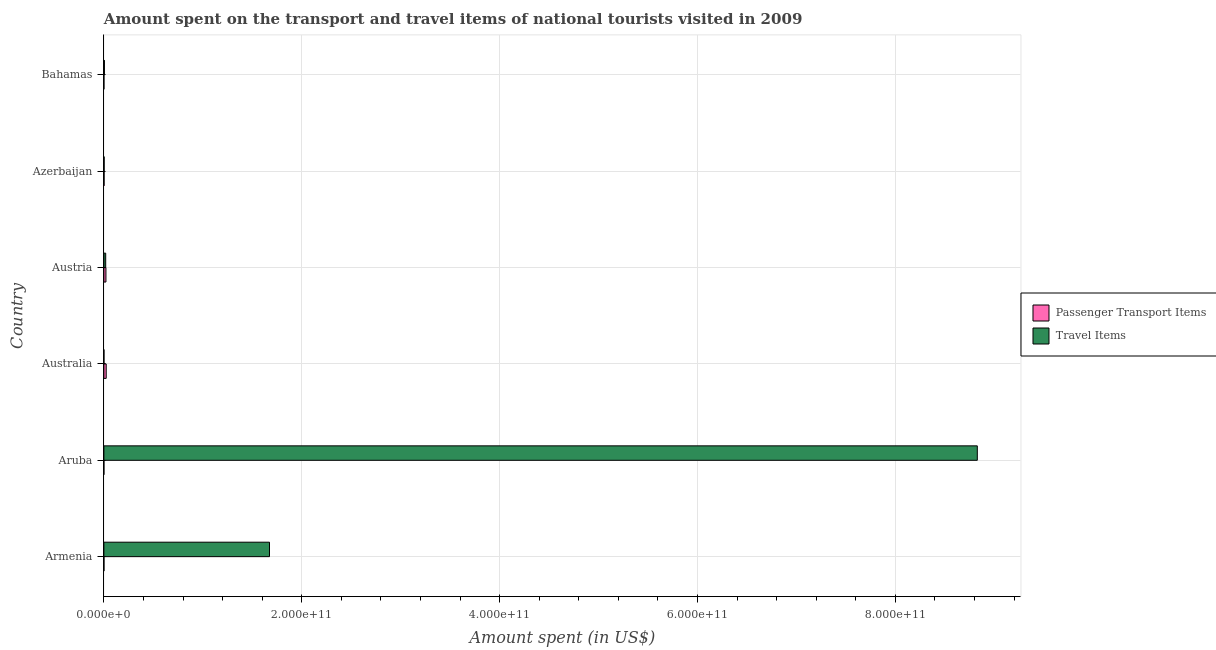How many different coloured bars are there?
Provide a succinct answer. 2. How many groups of bars are there?
Provide a short and direct response. 6. Are the number of bars per tick equal to the number of legend labels?
Provide a short and direct response. Yes. How many bars are there on the 4th tick from the bottom?
Your response must be concise. 2. What is the amount spent on passenger transport items in Aruba?
Offer a terse response. 1.20e+06. Across all countries, what is the maximum amount spent in travel items?
Provide a short and direct response. 8.83e+11. Across all countries, what is the minimum amount spent in travel items?
Keep it short and to the point. 3.90e+07. In which country was the amount spent in travel items maximum?
Keep it short and to the point. Aruba. In which country was the amount spent in travel items minimum?
Ensure brevity in your answer.  Australia. What is the total amount spent in travel items in the graph?
Your answer should be compact. 1.05e+12. What is the difference between the amount spent on passenger transport items in Australia and that in Azerbaijan?
Provide a succinct answer. 2.18e+09. What is the difference between the amount spent in travel items in Australia and the amount spent on passenger transport items in Azerbaijan?
Offer a terse response. -1.27e+08. What is the average amount spent on passenger transport items per country?
Ensure brevity in your answer.  7.70e+08. What is the difference between the amount spent in travel items and amount spent on passenger transport items in Australia?
Keep it short and to the point. -2.30e+09. In how many countries, is the amount spent on passenger transport items greater than 160000000000 US$?
Your answer should be very brief. 0. What is the ratio of the amount spent on passenger transport items in Austria to that in Bahamas?
Give a very brief answer. 187.36. What is the difference between the highest and the second highest amount spent in travel items?
Offer a very short reply. 7.15e+11. What is the difference between the highest and the lowest amount spent on passenger transport items?
Your answer should be very brief. 2.34e+09. In how many countries, is the amount spent on passenger transport items greater than the average amount spent on passenger transport items taken over all countries?
Ensure brevity in your answer.  2. Is the sum of the amount spent in travel items in Aruba and Austria greater than the maximum amount spent on passenger transport items across all countries?
Your response must be concise. Yes. What does the 1st bar from the top in Azerbaijan represents?
Make the answer very short. Travel Items. What does the 1st bar from the bottom in Armenia represents?
Provide a short and direct response. Passenger Transport Items. Are all the bars in the graph horizontal?
Keep it short and to the point. Yes. How many countries are there in the graph?
Keep it short and to the point. 6. What is the difference between two consecutive major ticks on the X-axis?
Provide a short and direct response. 2.00e+11. Are the values on the major ticks of X-axis written in scientific E-notation?
Keep it short and to the point. Yes. How many legend labels are there?
Your answer should be compact. 2. What is the title of the graph?
Give a very brief answer. Amount spent on the transport and travel items of national tourists visited in 2009. What is the label or title of the X-axis?
Provide a short and direct response. Amount spent (in US$). What is the Amount spent (in US$) in Passenger Transport Items in Armenia?
Your answer should be compact. 4.00e+07. What is the Amount spent (in US$) in Travel Items in Armenia?
Ensure brevity in your answer.  1.67e+11. What is the Amount spent (in US$) of Passenger Transport Items in Aruba?
Ensure brevity in your answer.  1.20e+06. What is the Amount spent (in US$) in Travel Items in Aruba?
Keep it short and to the point. 8.83e+11. What is the Amount spent (in US$) in Passenger Transport Items in Australia?
Your response must be concise. 2.34e+09. What is the Amount spent (in US$) in Travel Items in Australia?
Offer a very short reply. 3.90e+07. What is the Amount spent (in US$) of Passenger Transport Items in Austria?
Make the answer very short. 2.06e+09. What is the Amount spent (in US$) in Travel Items in Austria?
Your answer should be very brief. 1.83e+09. What is the Amount spent (in US$) of Passenger Transport Items in Azerbaijan?
Make the answer very short. 1.66e+08. What is the Amount spent (in US$) in Travel Items in Azerbaijan?
Keep it short and to the point. 2.46e+08. What is the Amount spent (in US$) of Passenger Transport Items in Bahamas?
Provide a short and direct response. 1.10e+07. What is the Amount spent (in US$) of Travel Items in Bahamas?
Make the answer very short. 5.34e+08. Across all countries, what is the maximum Amount spent (in US$) of Passenger Transport Items?
Ensure brevity in your answer.  2.34e+09. Across all countries, what is the maximum Amount spent (in US$) of Travel Items?
Provide a short and direct response. 8.83e+11. Across all countries, what is the minimum Amount spent (in US$) in Passenger Transport Items?
Your response must be concise. 1.20e+06. Across all countries, what is the minimum Amount spent (in US$) in Travel Items?
Ensure brevity in your answer.  3.90e+07. What is the total Amount spent (in US$) of Passenger Transport Items in the graph?
Provide a short and direct response. 4.62e+09. What is the total Amount spent (in US$) in Travel Items in the graph?
Provide a short and direct response. 1.05e+12. What is the difference between the Amount spent (in US$) of Passenger Transport Items in Armenia and that in Aruba?
Ensure brevity in your answer.  3.88e+07. What is the difference between the Amount spent (in US$) in Travel Items in Armenia and that in Aruba?
Offer a very short reply. -7.15e+11. What is the difference between the Amount spent (in US$) of Passenger Transport Items in Armenia and that in Australia?
Ensure brevity in your answer.  -2.30e+09. What is the difference between the Amount spent (in US$) in Travel Items in Armenia and that in Australia?
Make the answer very short. 1.67e+11. What is the difference between the Amount spent (in US$) of Passenger Transport Items in Armenia and that in Austria?
Keep it short and to the point. -2.02e+09. What is the difference between the Amount spent (in US$) in Travel Items in Armenia and that in Austria?
Provide a succinct answer. 1.66e+11. What is the difference between the Amount spent (in US$) of Passenger Transport Items in Armenia and that in Azerbaijan?
Your answer should be compact. -1.26e+08. What is the difference between the Amount spent (in US$) in Travel Items in Armenia and that in Azerbaijan?
Provide a short and direct response. 1.67e+11. What is the difference between the Amount spent (in US$) in Passenger Transport Items in Armenia and that in Bahamas?
Your answer should be very brief. 2.90e+07. What is the difference between the Amount spent (in US$) of Travel Items in Armenia and that in Bahamas?
Keep it short and to the point. 1.67e+11. What is the difference between the Amount spent (in US$) of Passenger Transport Items in Aruba and that in Australia?
Offer a very short reply. -2.34e+09. What is the difference between the Amount spent (in US$) of Travel Items in Aruba and that in Australia?
Offer a terse response. 8.83e+11. What is the difference between the Amount spent (in US$) of Passenger Transport Items in Aruba and that in Austria?
Provide a succinct answer. -2.06e+09. What is the difference between the Amount spent (in US$) of Travel Items in Aruba and that in Austria?
Provide a succinct answer. 8.81e+11. What is the difference between the Amount spent (in US$) in Passenger Transport Items in Aruba and that in Azerbaijan?
Give a very brief answer. -1.65e+08. What is the difference between the Amount spent (in US$) in Travel Items in Aruba and that in Azerbaijan?
Provide a short and direct response. 8.83e+11. What is the difference between the Amount spent (in US$) in Passenger Transport Items in Aruba and that in Bahamas?
Your answer should be very brief. -9.80e+06. What is the difference between the Amount spent (in US$) of Travel Items in Aruba and that in Bahamas?
Offer a terse response. 8.82e+11. What is the difference between the Amount spent (in US$) in Passenger Transport Items in Australia and that in Austria?
Provide a short and direct response. 2.82e+08. What is the difference between the Amount spent (in US$) of Travel Items in Australia and that in Austria?
Provide a succinct answer. -1.79e+09. What is the difference between the Amount spent (in US$) in Passenger Transport Items in Australia and that in Azerbaijan?
Your answer should be compact. 2.18e+09. What is the difference between the Amount spent (in US$) of Travel Items in Australia and that in Azerbaijan?
Your answer should be compact. -2.07e+08. What is the difference between the Amount spent (in US$) of Passenger Transport Items in Australia and that in Bahamas?
Keep it short and to the point. 2.33e+09. What is the difference between the Amount spent (in US$) of Travel Items in Australia and that in Bahamas?
Offer a very short reply. -4.95e+08. What is the difference between the Amount spent (in US$) in Passenger Transport Items in Austria and that in Azerbaijan?
Keep it short and to the point. 1.90e+09. What is the difference between the Amount spent (in US$) of Travel Items in Austria and that in Azerbaijan?
Your response must be concise. 1.58e+09. What is the difference between the Amount spent (in US$) of Passenger Transport Items in Austria and that in Bahamas?
Make the answer very short. 2.05e+09. What is the difference between the Amount spent (in US$) in Travel Items in Austria and that in Bahamas?
Make the answer very short. 1.30e+09. What is the difference between the Amount spent (in US$) in Passenger Transport Items in Azerbaijan and that in Bahamas?
Provide a short and direct response. 1.55e+08. What is the difference between the Amount spent (in US$) in Travel Items in Azerbaijan and that in Bahamas?
Keep it short and to the point. -2.88e+08. What is the difference between the Amount spent (in US$) in Passenger Transport Items in Armenia and the Amount spent (in US$) in Travel Items in Aruba?
Provide a succinct answer. -8.83e+11. What is the difference between the Amount spent (in US$) in Passenger Transport Items in Armenia and the Amount spent (in US$) in Travel Items in Austria?
Make the answer very short. -1.79e+09. What is the difference between the Amount spent (in US$) in Passenger Transport Items in Armenia and the Amount spent (in US$) in Travel Items in Azerbaijan?
Provide a succinct answer. -2.06e+08. What is the difference between the Amount spent (in US$) of Passenger Transport Items in Armenia and the Amount spent (in US$) of Travel Items in Bahamas?
Provide a short and direct response. -4.94e+08. What is the difference between the Amount spent (in US$) of Passenger Transport Items in Aruba and the Amount spent (in US$) of Travel Items in Australia?
Offer a very short reply. -3.78e+07. What is the difference between the Amount spent (in US$) of Passenger Transport Items in Aruba and the Amount spent (in US$) of Travel Items in Austria?
Keep it short and to the point. -1.83e+09. What is the difference between the Amount spent (in US$) of Passenger Transport Items in Aruba and the Amount spent (in US$) of Travel Items in Azerbaijan?
Ensure brevity in your answer.  -2.45e+08. What is the difference between the Amount spent (in US$) of Passenger Transport Items in Aruba and the Amount spent (in US$) of Travel Items in Bahamas?
Give a very brief answer. -5.33e+08. What is the difference between the Amount spent (in US$) in Passenger Transport Items in Australia and the Amount spent (in US$) in Travel Items in Austria?
Give a very brief answer. 5.14e+08. What is the difference between the Amount spent (in US$) in Passenger Transport Items in Australia and the Amount spent (in US$) in Travel Items in Azerbaijan?
Offer a very short reply. 2.10e+09. What is the difference between the Amount spent (in US$) in Passenger Transport Items in Australia and the Amount spent (in US$) in Travel Items in Bahamas?
Offer a terse response. 1.81e+09. What is the difference between the Amount spent (in US$) in Passenger Transport Items in Austria and the Amount spent (in US$) in Travel Items in Azerbaijan?
Offer a terse response. 1.82e+09. What is the difference between the Amount spent (in US$) in Passenger Transport Items in Austria and the Amount spent (in US$) in Travel Items in Bahamas?
Give a very brief answer. 1.53e+09. What is the difference between the Amount spent (in US$) in Passenger Transport Items in Azerbaijan and the Amount spent (in US$) in Travel Items in Bahamas?
Provide a succinct answer. -3.68e+08. What is the average Amount spent (in US$) in Passenger Transport Items per country?
Your answer should be compact. 7.70e+08. What is the average Amount spent (in US$) in Travel Items per country?
Your answer should be compact. 1.75e+11. What is the difference between the Amount spent (in US$) in Passenger Transport Items and Amount spent (in US$) in Travel Items in Armenia?
Provide a succinct answer. -1.67e+11. What is the difference between the Amount spent (in US$) of Passenger Transport Items and Amount spent (in US$) of Travel Items in Aruba?
Provide a succinct answer. -8.83e+11. What is the difference between the Amount spent (in US$) in Passenger Transport Items and Amount spent (in US$) in Travel Items in Australia?
Provide a succinct answer. 2.30e+09. What is the difference between the Amount spent (in US$) of Passenger Transport Items and Amount spent (in US$) of Travel Items in Austria?
Your response must be concise. 2.32e+08. What is the difference between the Amount spent (in US$) in Passenger Transport Items and Amount spent (in US$) in Travel Items in Azerbaijan?
Your response must be concise. -8.00e+07. What is the difference between the Amount spent (in US$) in Passenger Transport Items and Amount spent (in US$) in Travel Items in Bahamas?
Your answer should be compact. -5.23e+08. What is the ratio of the Amount spent (in US$) in Passenger Transport Items in Armenia to that in Aruba?
Make the answer very short. 33.33. What is the ratio of the Amount spent (in US$) in Travel Items in Armenia to that in Aruba?
Ensure brevity in your answer.  0.19. What is the ratio of the Amount spent (in US$) in Passenger Transport Items in Armenia to that in Australia?
Give a very brief answer. 0.02. What is the ratio of the Amount spent (in US$) in Travel Items in Armenia to that in Australia?
Your answer should be very brief. 4291.87. What is the ratio of the Amount spent (in US$) in Passenger Transport Items in Armenia to that in Austria?
Your response must be concise. 0.02. What is the ratio of the Amount spent (in US$) in Travel Items in Armenia to that in Austria?
Your answer should be very brief. 91.52. What is the ratio of the Amount spent (in US$) of Passenger Transport Items in Armenia to that in Azerbaijan?
Provide a short and direct response. 0.24. What is the ratio of the Amount spent (in US$) of Travel Items in Armenia to that in Azerbaijan?
Provide a succinct answer. 680.42. What is the ratio of the Amount spent (in US$) in Passenger Transport Items in Armenia to that in Bahamas?
Ensure brevity in your answer.  3.64. What is the ratio of the Amount spent (in US$) of Travel Items in Armenia to that in Bahamas?
Give a very brief answer. 313.45. What is the ratio of the Amount spent (in US$) of Travel Items in Aruba to that in Australia?
Your answer should be compact. 2.26e+04. What is the ratio of the Amount spent (in US$) in Passenger Transport Items in Aruba to that in Austria?
Make the answer very short. 0. What is the ratio of the Amount spent (in US$) of Travel Items in Aruba to that in Austria?
Your answer should be compact. 482.67. What is the ratio of the Amount spent (in US$) in Passenger Transport Items in Aruba to that in Azerbaijan?
Make the answer very short. 0.01. What is the ratio of the Amount spent (in US$) of Travel Items in Aruba to that in Azerbaijan?
Offer a terse response. 3588.62. What is the ratio of the Amount spent (in US$) of Passenger Transport Items in Aruba to that in Bahamas?
Offer a very short reply. 0.11. What is the ratio of the Amount spent (in US$) of Travel Items in Aruba to that in Bahamas?
Give a very brief answer. 1653.19. What is the ratio of the Amount spent (in US$) in Passenger Transport Items in Australia to that in Austria?
Give a very brief answer. 1.14. What is the ratio of the Amount spent (in US$) of Travel Items in Australia to that in Austria?
Your answer should be very brief. 0.02. What is the ratio of the Amount spent (in US$) in Passenger Transport Items in Australia to that in Azerbaijan?
Your answer should be compact. 14.11. What is the ratio of the Amount spent (in US$) in Travel Items in Australia to that in Azerbaijan?
Your answer should be very brief. 0.16. What is the ratio of the Amount spent (in US$) of Passenger Transport Items in Australia to that in Bahamas?
Your response must be concise. 213. What is the ratio of the Amount spent (in US$) in Travel Items in Australia to that in Bahamas?
Your answer should be compact. 0.07. What is the ratio of the Amount spent (in US$) of Passenger Transport Items in Austria to that in Azerbaijan?
Offer a terse response. 12.42. What is the ratio of the Amount spent (in US$) of Travel Items in Austria to that in Azerbaijan?
Provide a succinct answer. 7.43. What is the ratio of the Amount spent (in US$) in Passenger Transport Items in Austria to that in Bahamas?
Your response must be concise. 187.36. What is the ratio of the Amount spent (in US$) in Travel Items in Austria to that in Bahamas?
Your answer should be compact. 3.43. What is the ratio of the Amount spent (in US$) of Passenger Transport Items in Azerbaijan to that in Bahamas?
Provide a succinct answer. 15.09. What is the ratio of the Amount spent (in US$) in Travel Items in Azerbaijan to that in Bahamas?
Keep it short and to the point. 0.46. What is the difference between the highest and the second highest Amount spent (in US$) in Passenger Transport Items?
Make the answer very short. 2.82e+08. What is the difference between the highest and the second highest Amount spent (in US$) of Travel Items?
Make the answer very short. 7.15e+11. What is the difference between the highest and the lowest Amount spent (in US$) of Passenger Transport Items?
Provide a succinct answer. 2.34e+09. What is the difference between the highest and the lowest Amount spent (in US$) in Travel Items?
Your answer should be very brief. 8.83e+11. 